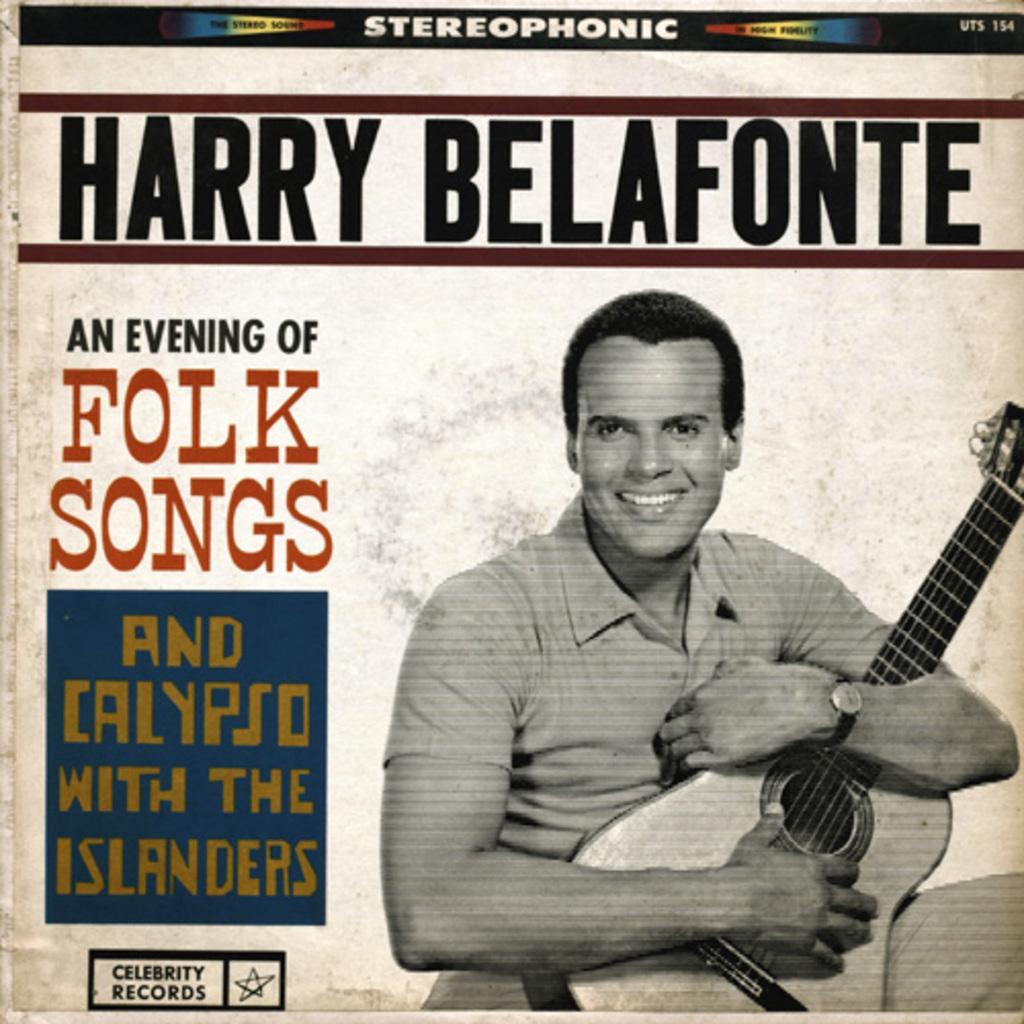In one or two sentences, can you explain what this image depicts? It is a poster. In this poster there is a person holding the guitar and we can see some text on the image. 